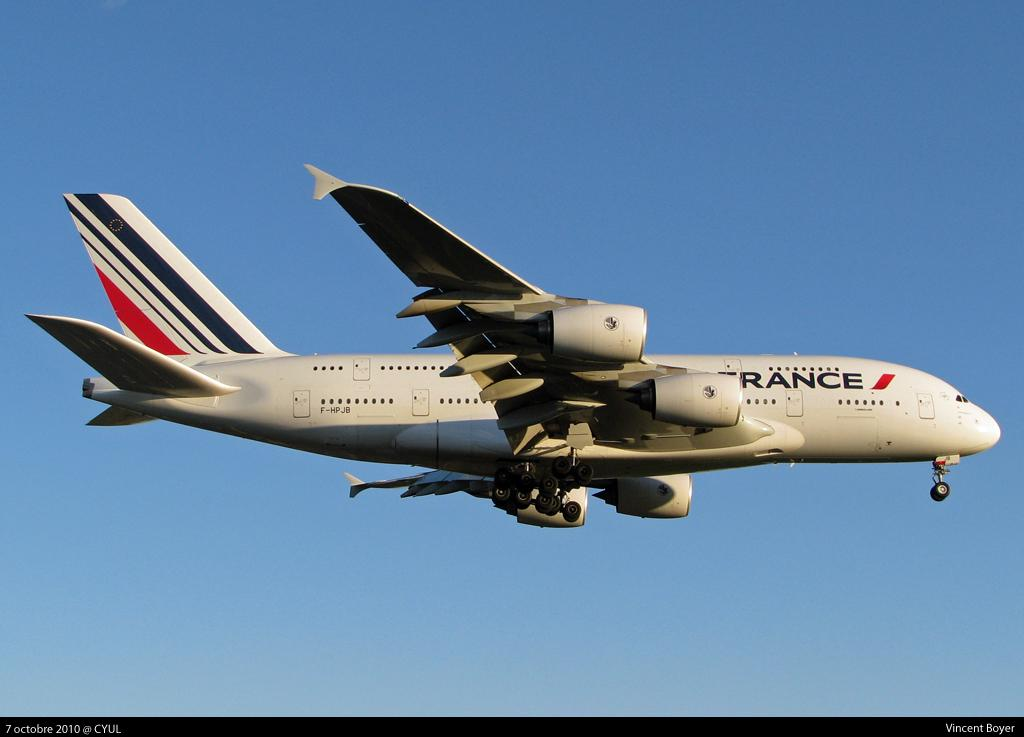Provide a one-sentence caption for the provided image. An Air France Jumbo jet in clear blue sky, taken from the ground. 